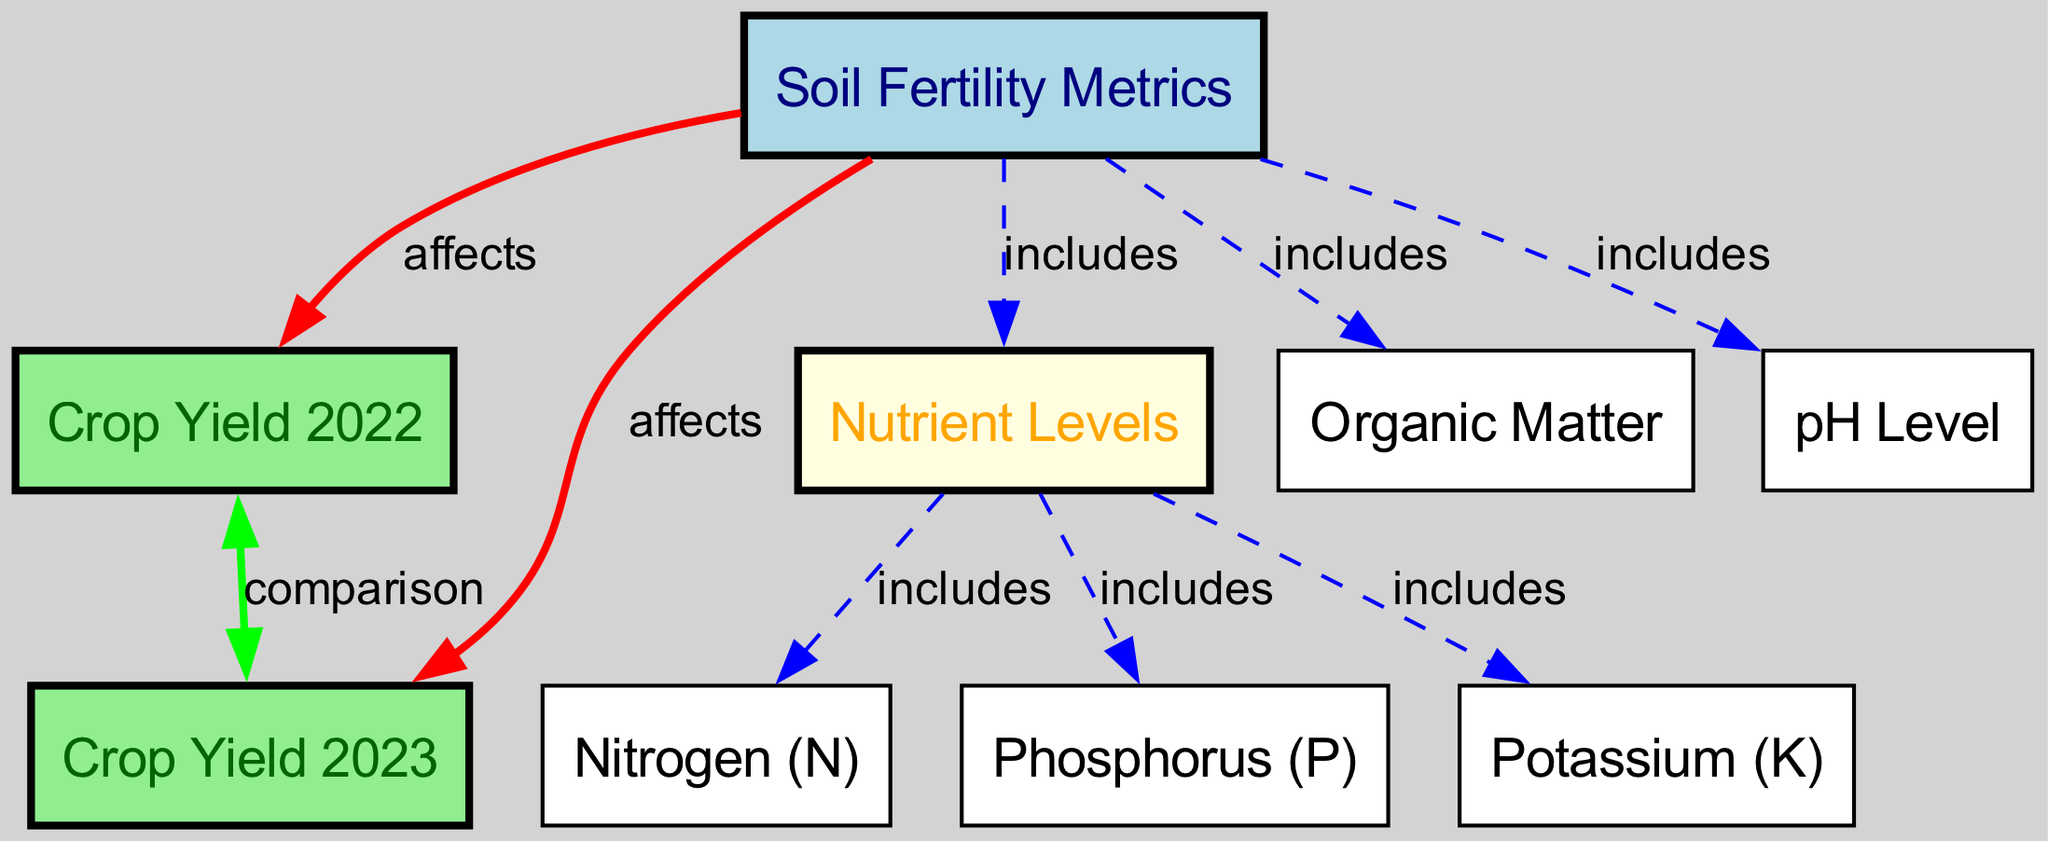What are the two crop yields compared in this diagram? The diagram includes nodes for "Crop Yield 2022" and "Crop Yield 2023," indicating these are the two crop yields being compared.
Answer: Crop Yield 2022, Crop Yield 2023 How many soil fertility metrics are included in the diagram? The diagram includes three distinct soil fertility metrics: nutrient levels, organic matter, and pH level, making a total of three metrics.
Answer: 3 Which nutrient levels are specified in the diagram? The diagram identifies three nutrient levels: nitrogen, phosphorus, and potassium as part of the nutrient levels node.
Answer: Nitrogen, Phosphorus, Potassium What type of relationship exists between soil fertility metrics and crop yield in 2022? The relationship is described by the "affects" label, indicating that soil fertility metrics directly affect the crop yield in 2022.
Answer: Affects Which nutrients are included under the nutrient levels node? The nutrient levels node includes nitrogen, phosphorus, and potassium, indicating these are specific nutrients being measured.
Answer: Nitrogen, Phosphorus, Potassium If soil fertility metrics improve, what is the expected outcome for crop yield based on the diagram? The diagram suggests that an improvement in soil fertility metrics will positively affect the crop yields for both years 2022 and 2023, as shown by the direct "affects" connections.
Answer: Increase in crop yield What is the type of edge connecting crop yield 2022 and crop yield 2023? The edge connecting these two nodes is labeled "comparison," which demonstrates that the two crop yields are being compared with one another.
Answer: Comparison How does nutrient levels relate to soil fertility metrics? The relationship is that nutrient levels are included within the broader category of soil fertility metrics, as indicated by the "includes" label.
Answer: Includes What color represents the crop yield nodes in the diagram? The crop yield nodes are colored light green, which distinguishes them visually from the other nodes in the diagram.
Answer: Light green 